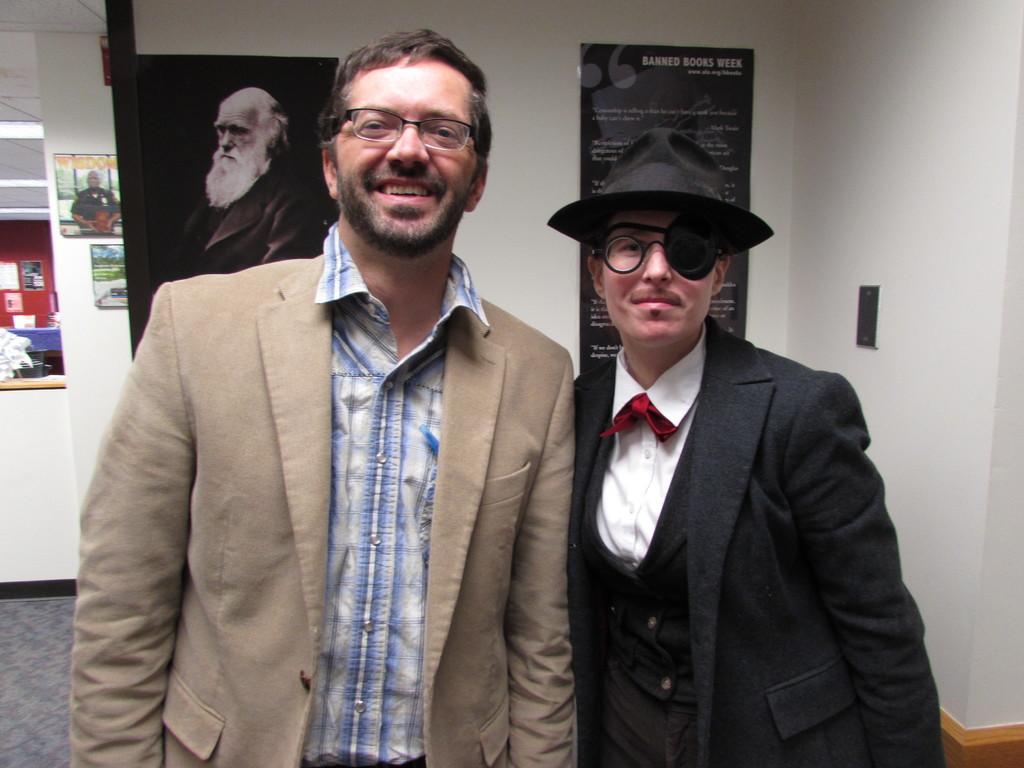Please provide a concise description of this image. In the center of the image there are two persons standing and wearing glasses. In the background there are two persons photography, posters attached to the wall. In the left there is also posters attached to the red wall. In the bottom floor is visible. 